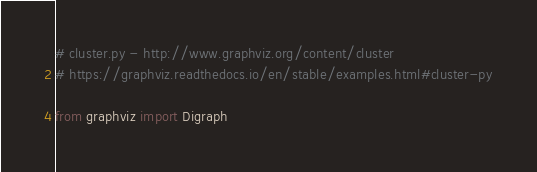Convert code to text. <code><loc_0><loc_0><loc_500><loc_500><_Python_># cluster.py - http://www.graphviz.org/content/cluster
# https://graphviz.readthedocs.io/en/stable/examples.html#cluster-py

from graphviz import Digraph
</code> 